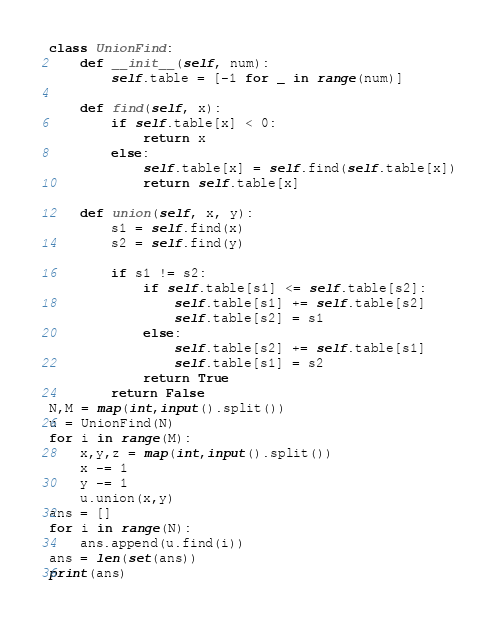<code> <loc_0><loc_0><loc_500><loc_500><_Python_>class UnionFind:
    def __init__(self, num):
        self.table = [-1 for _ in range(num)]

    def find(self, x):
        if self.table[x] < 0:
            return x
        else:
            self.table[x] = self.find(self.table[x])
            return self.table[x]

    def union(self, x, y):
        s1 = self.find(x)
        s2 = self.find(y)

        if s1 != s2:
            if self.table[s1] <= self.table[s2]:
                self.table[s1] += self.table[s2]
                self.table[s2] = s1
            else:
                self.table[s2] += self.table[s1]
                self.table[s1] = s2
            return True
        return False
N,M = map(int,input().split())
u = UnionFind(N)
for i in range(M):
    x,y,z = map(int,input().split())
    x -= 1
    y -= 1
    u.union(x,y)
ans = []
for i in range(N):
    ans.append(u.find(i))
ans = len(set(ans))
print(ans)</code> 